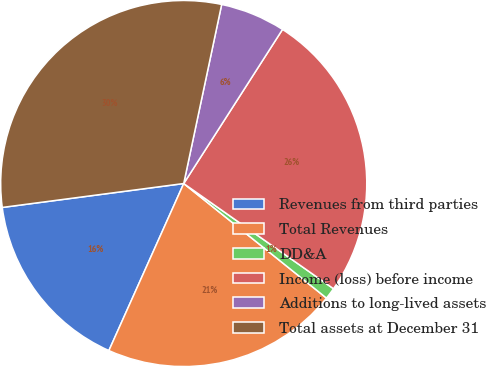Convert chart. <chart><loc_0><loc_0><loc_500><loc_500><pie_chart><fcel>Revenues from third parties<fcel>Total Revenues<fcel>DD&A<fcel>Income (loss) before income<fcel>Additions to long-lived assets<fcel>Total assets at December 31<nl><fcel>16.21%<fcel>20.94%<fcel>1.02%<fcel>25.67%<fcel>5.75%<fcel>30.41%<nl></chart> 